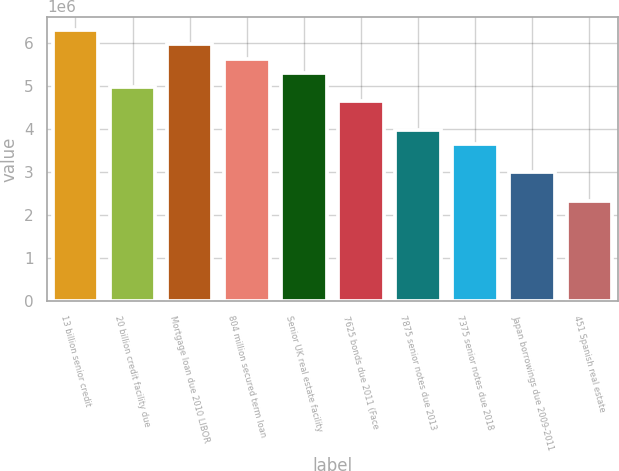<chart> <loc_0><loc_0><loc_500><loc_500><bar_chart><fcel>13 billion senior credit<fcel>20 billion credit facility due<fcel>Mortgage loan due 2010 LIBOR<fcel>804 million secured term loan<fcel>Senior UK real estate facility<fcel>7625 bonds due 2011 (Face<fcel>7875 senior notes due 2013<fcel>7375 senior notes due 2018<fcel>Japan borrowings due 2009-2011<fcel>451 Spanish real estate<nl><fcel>6.2896e+06<fcel>4.96989e+06<fcel>5.95967e+06<fcel>5.62974e+06<fcel>5.29982e+06<fcel>4.63997e+06<fcel>3.98011e+06<fcel>3.65019e+06<fcel>2.99033e+06<fcel>2.33048e+06<nl></chart> 